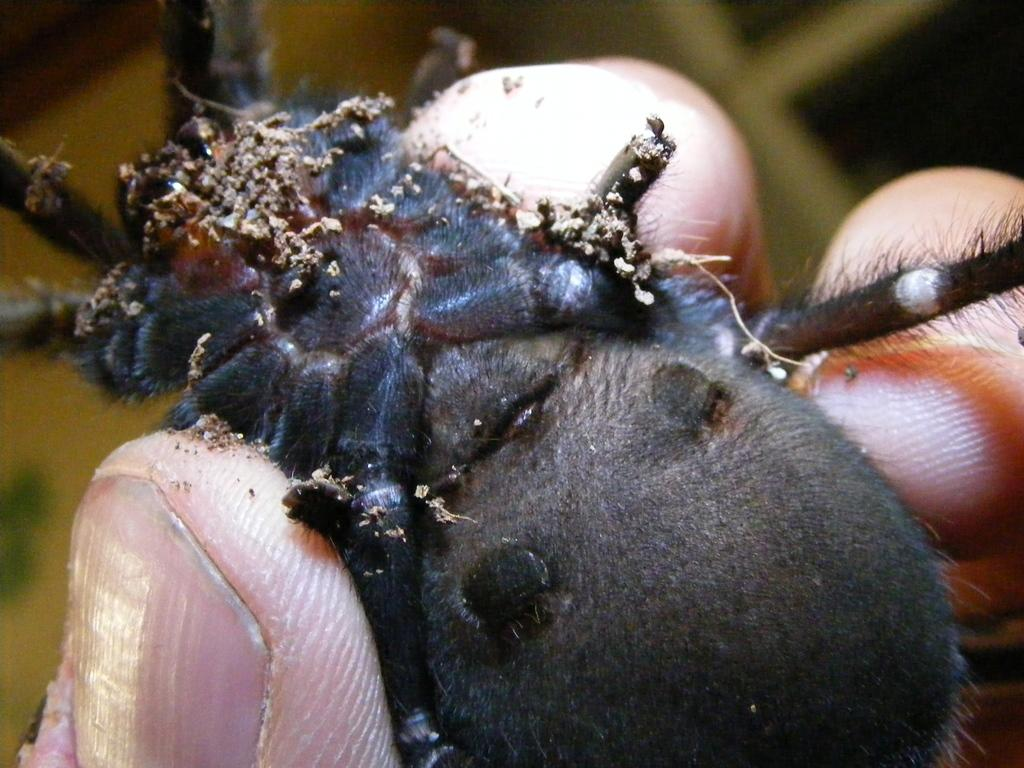What type of creature is present in the image? There is an insect in the image. Where is the insect located in the image? The insect is on a person's fingers. What type of airplane can be seen flying over the ocean in the image? There is no airplane or ocean present in the image; it only features an insect on a person's fingers. 